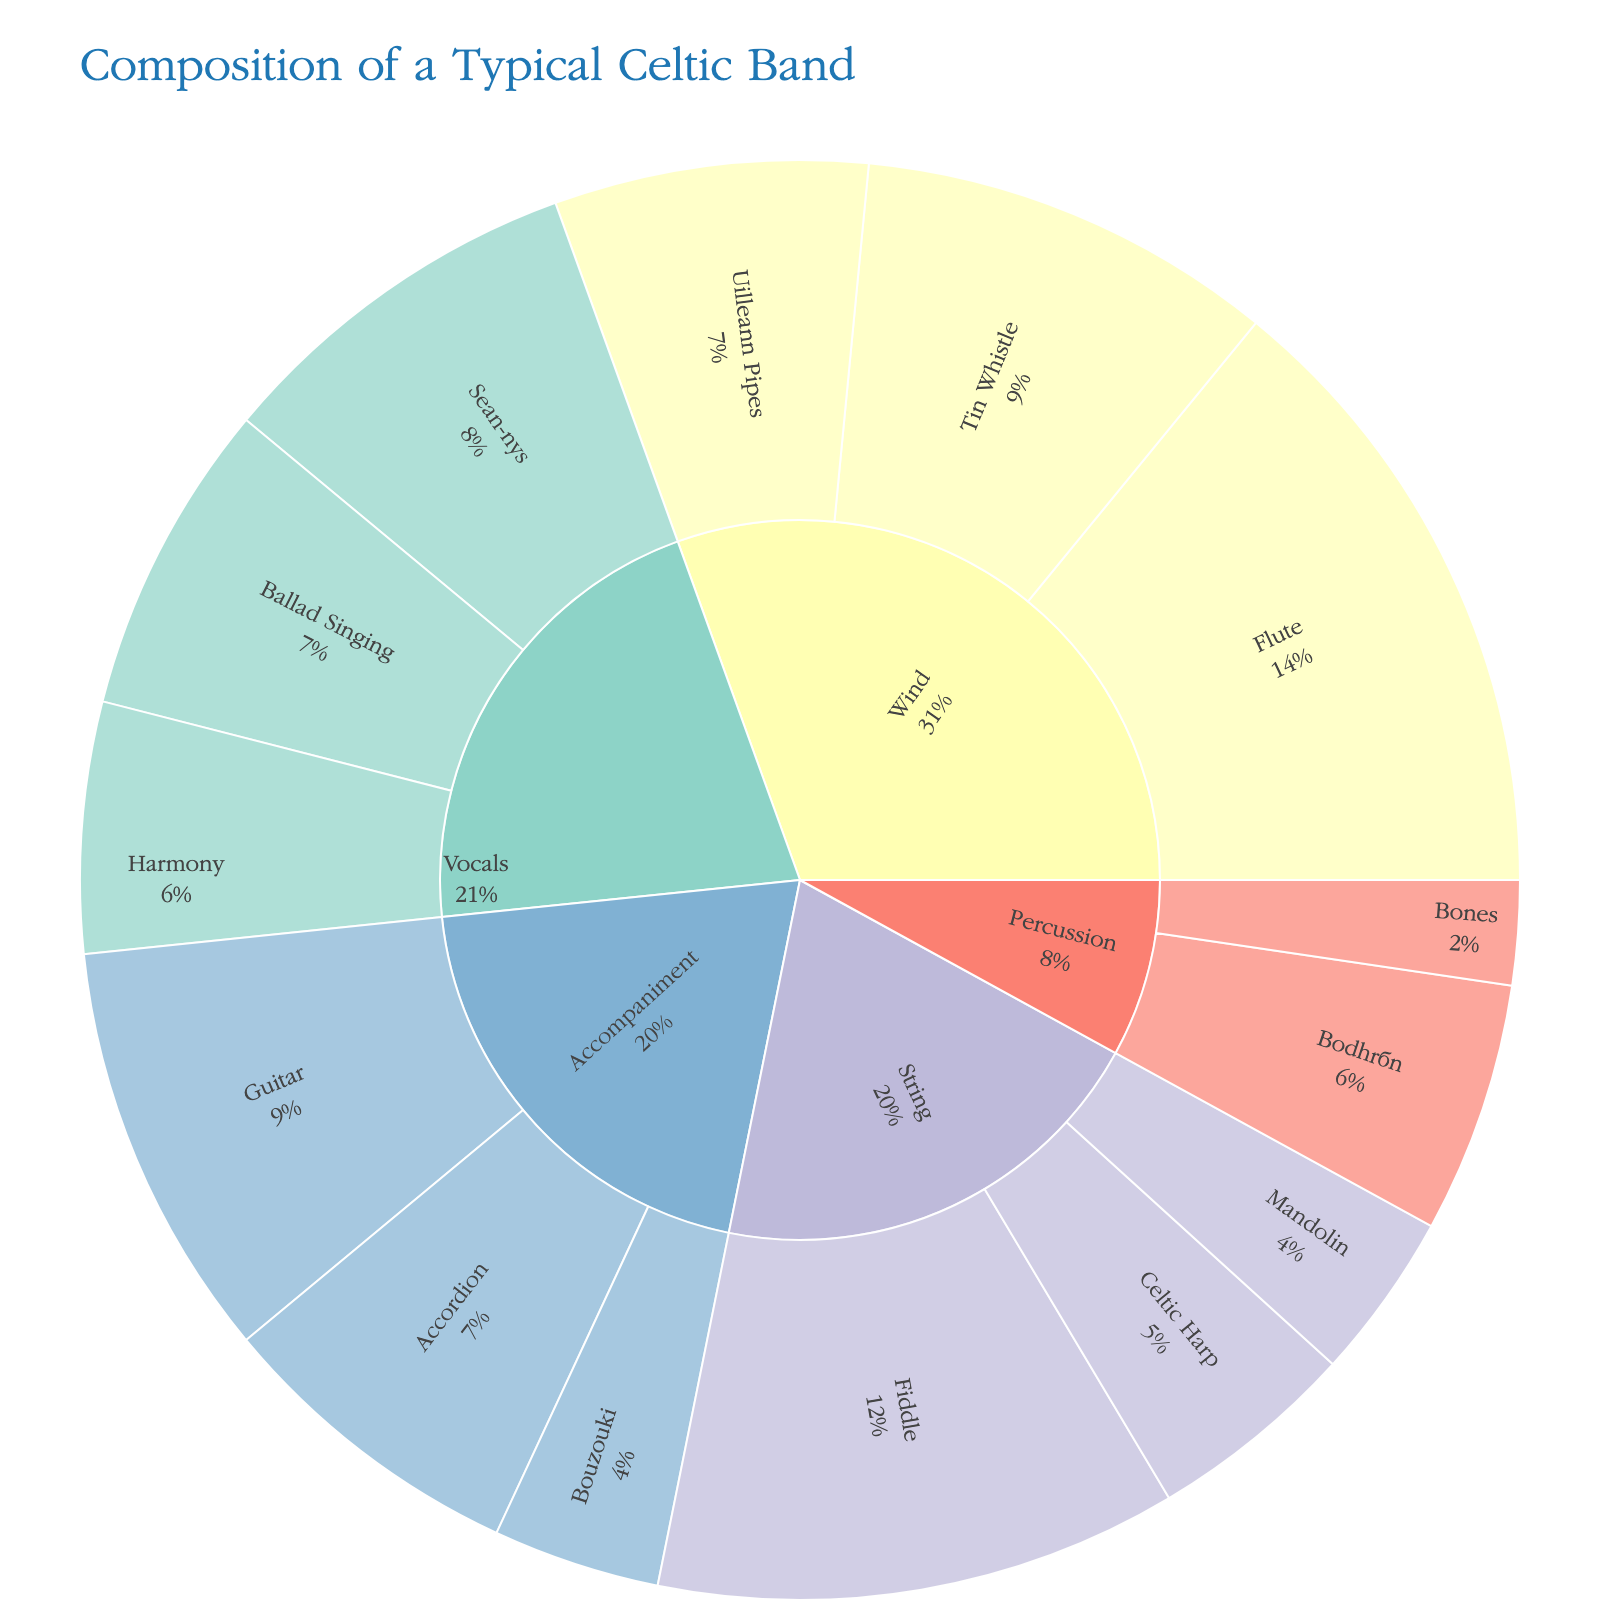What is the title of the figure? The title is usually placed prominently at the top of the figure. In this case, the title given in the code is "Composition of a Typical Celtic Band".
Answer: Composition of a Typical Celtic Band Which instrument has the highest value among Wind instruments? Observe the Wind category and then compare the values of each subcategory. The Flute has a value of 30, which is the highest among Wind instruments.
Answer: Flute How many more Flutes than Tin Whistles are there? We need to subtract the value of Tin Whistles from the value of Flutes. Flutes have a value of 30 and Tin Whistles have a value of 20. So, 30 - 20 = 10.
Answer: 10 What percentage of the overall composition does the Fiddle contribute? To find the percentage, we need to know the total value. Summing the given values: 30 + 20 + 15 + 25 + 10 + 8 + 12 + 5 + 18 + 15 + 12 + 20 + 8 + 15 = 213. The Fiddle has a value of 25. Thus, (25/213) * 100 ≈ 11.74%.
Answer: 11.74% Which category has the smallest total value? We sum the values for each category. Wind: 30 + 20 + 15 = 65, String: 25 + 10 + 8 = 43, Percussion: 12 + 5 = 17, Vocals: 18 + 15 + 12 = 45, Accompaniment: 20 + 8 + 15 = 43. The Percussion category has the smallest total value of 17.
Answer: Percussion Is the value of Guitar equal to Accordion and Uilleann Pipes combined? Sum the values of Accordion and Uilleann Pipes. Accordion has a value of 15, and Uilleann Pipes have a value of 15. So, 15 + 15 = 30, which is equal to the value of the Guitar.
Answer: Yes What is the total value for all Vocal styles combined? Sum the values for all Vocal styles. Sean-nós: 18, Ballad Singing: 15, Harmony: 12. So, 18 + 15 + 12 = 45.
Answer: 45 Which subcategory under Accompaniment has the lowest value? Compare the values of Guitar, Bouzouki, and Accordion. Guitar has 20, Bouzouki has 8, and Accordion has 15. Bouzouki has the lowest value of 8.
Answer: Bouzouki How does the value of Bodhrán compare to Bones? Compare the values directly. Bodhrán has a value of 12, while Bones has a value of 5. Bodhrán has a higher value than Bones.
Answer: Bodhrán is greater What is the ratio of Flutes to Fiddles? Divide the value of Flutes by the value of Fiddles. Flutes: 30, Fiddles: 25. So, 30 / 25 = 1.2.
Answer: 1.2 